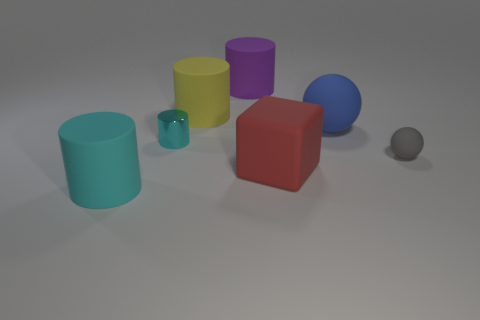Are there any other things that have the same material as the tiny cylinder?
Offer a terse response. No. Does the matte ball left of the tiny gray matte sphere have the same color as the small sphere?
Your answer should be very brief. No. How many spheres are large blue metallic objects or blue rubber objects?
Offer a very short reply. 1. How big is the cyan cylinder left of the cyan thing that is behind the cylinder in front of the red thing?
Provide a short and direct response. Large. There is a purple object that is the same size as the rubber cube; what is its shape?
Offer a very short reply. Cylinder. What shape is the small metallic thing?
Offer a very short reply. Cylinder. Is the material of the tiny thing behind the small rubber thing the same as the gray thing?
Provide a short and direct response. No. How big is the cyan thing that is on the right side of the big cylinder that is to the left of the yellow object?
Offer a terse response. Small. The large thing that is both behind the tiny matte object and on the right side of the big purple rubber cylinder is what color?
Keep it short and to the point. Blue. There is a cyan thing that is the same size as the yellow cylinder; what is it made of?
Offer a very short reply. Rubber. 